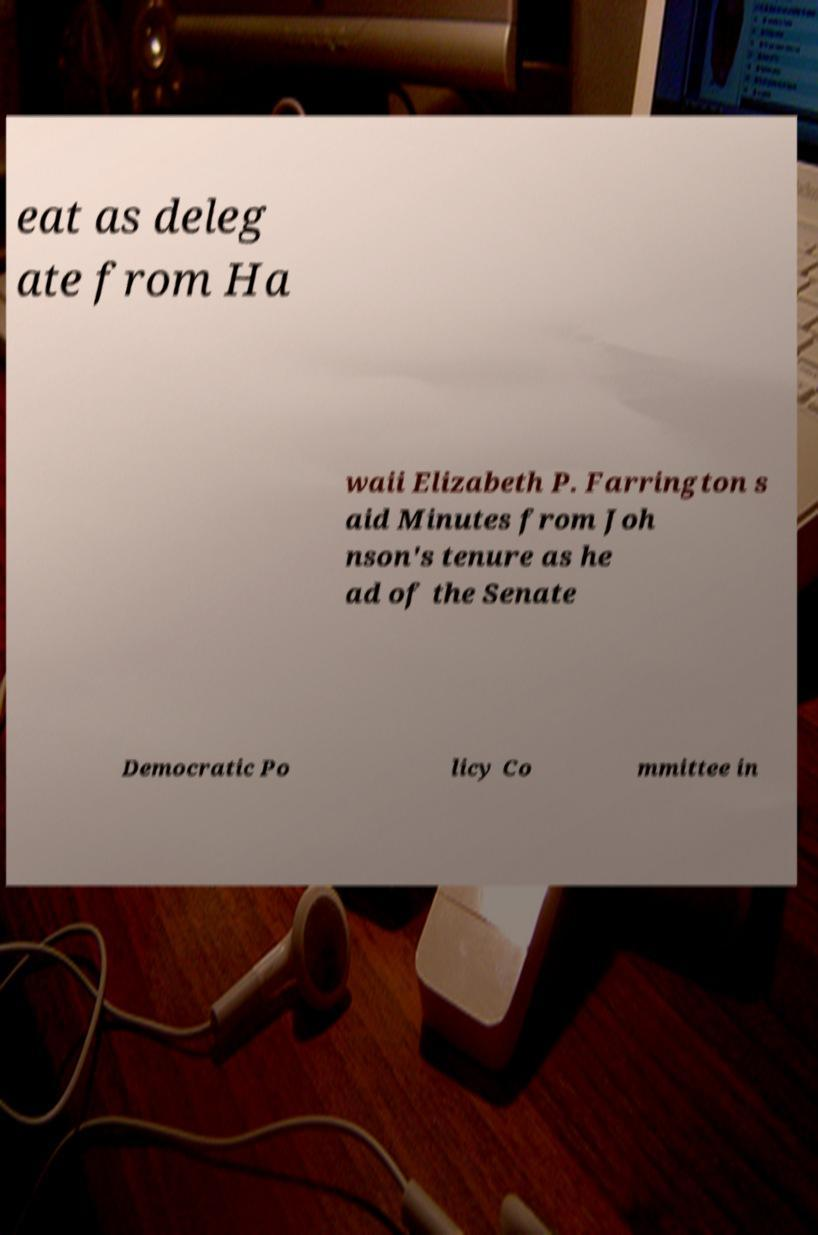Please read and relay the text visible in this image. What does it say? eat as deleg ate from Ha waii Elizabeth P. Farrington s aid Minutes from Joh nson's tenure as he ad of the Senate Democratic Po licy Co mmittee in 